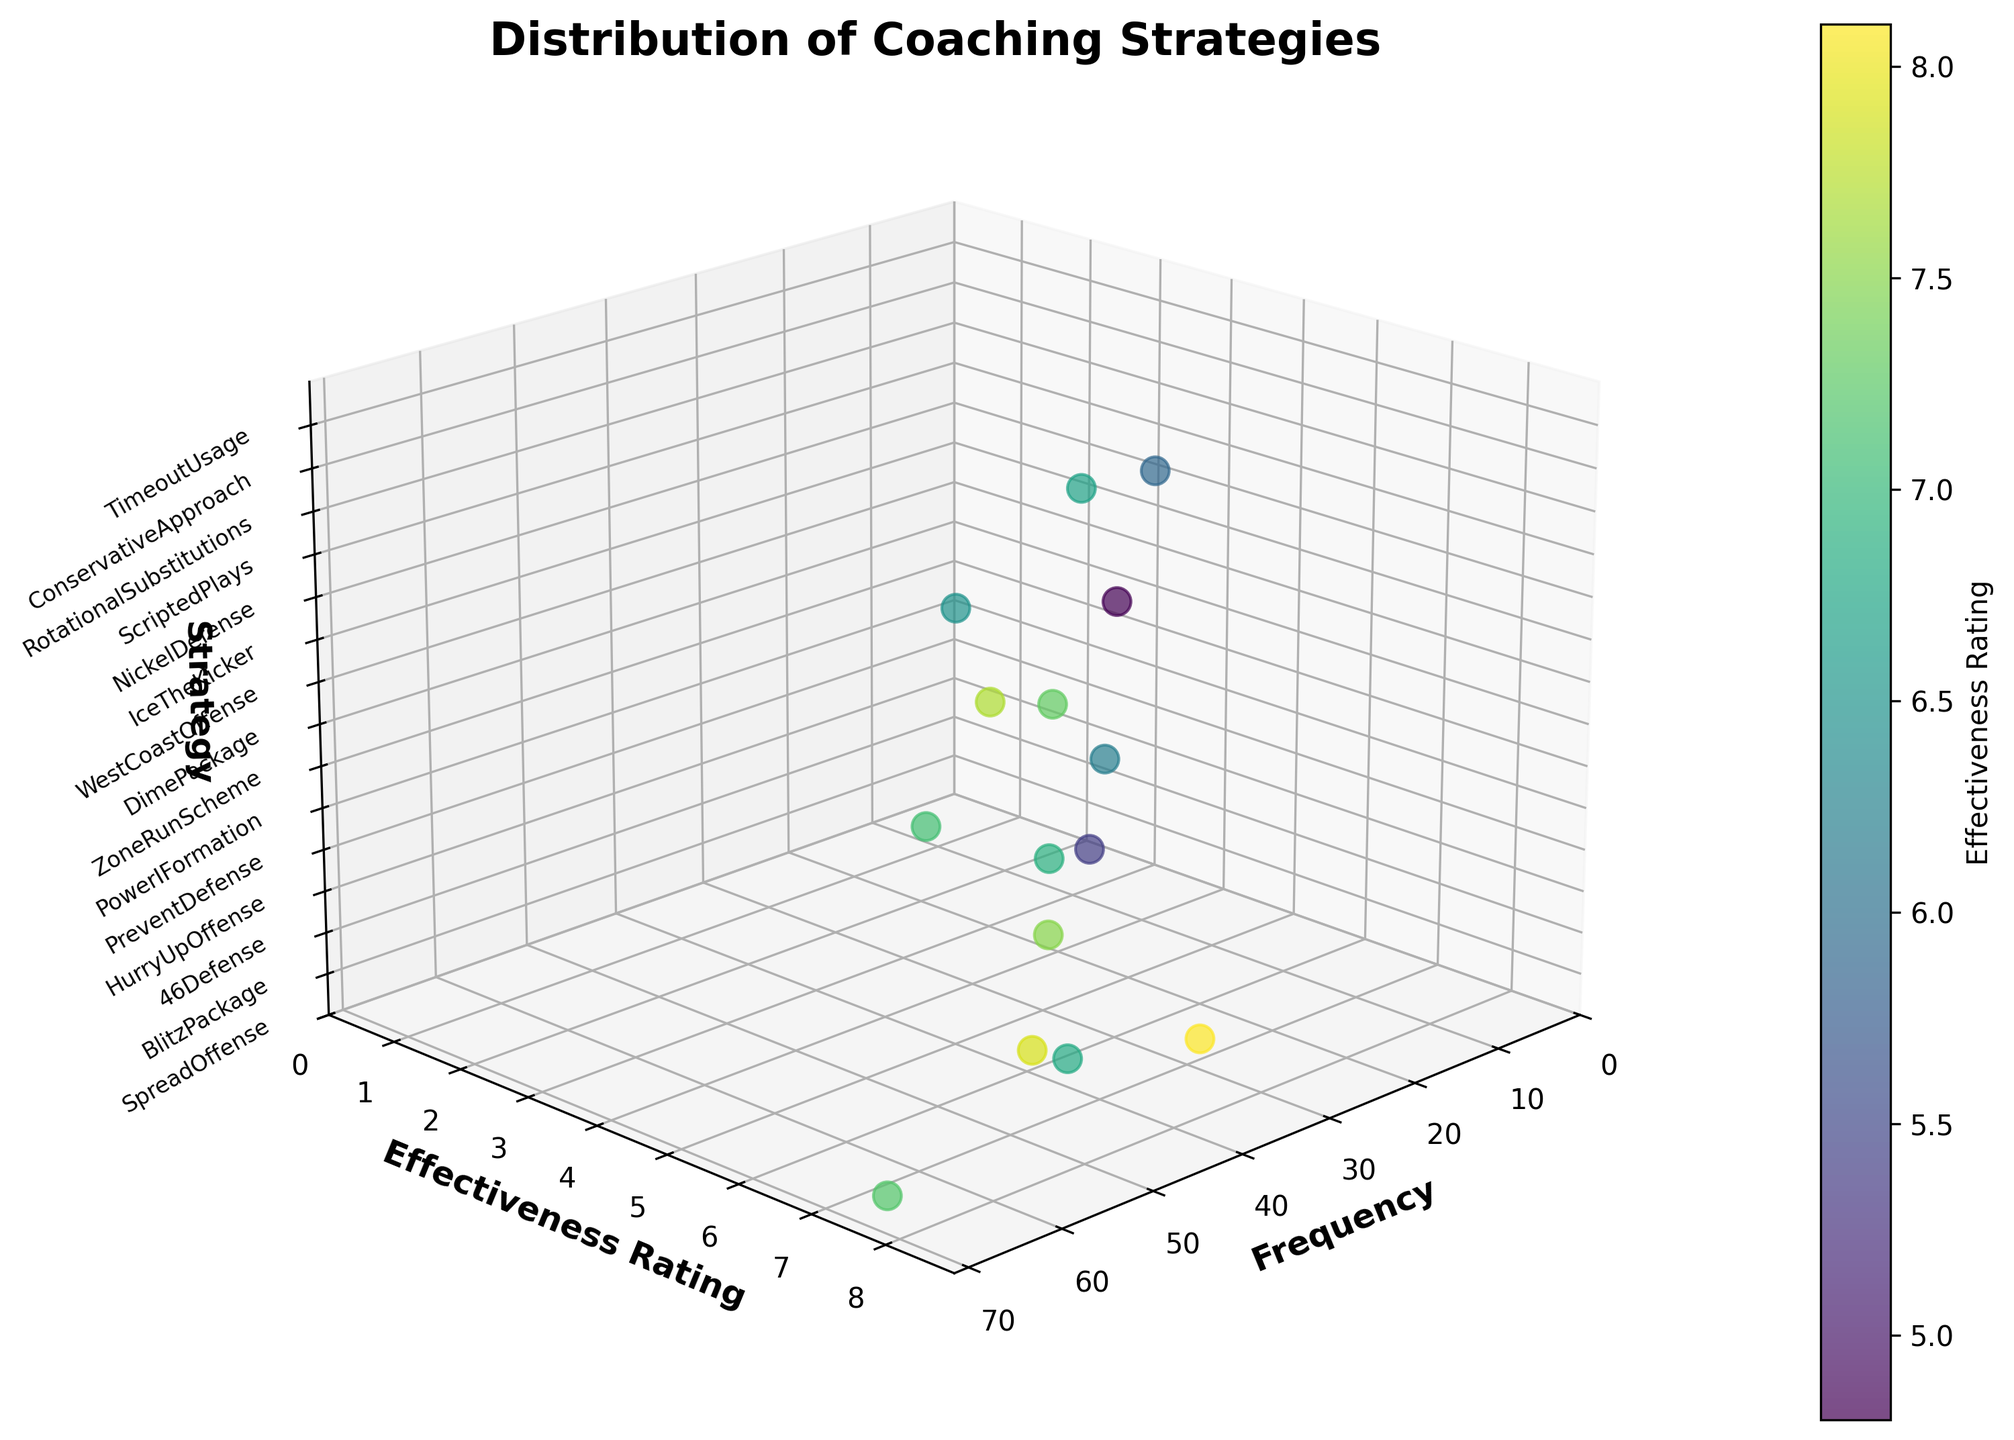What is the title of the figure? The title of the figure is always displayed at the top of the plot, providing a summary of the visual's content. In this case, the title is at the top of the 3D scatter plot.
Answer: Distribution of Coaching Strategies How many data points are represented in the scatter plot? The scatter plot has a specific number of data points representing the different strategies. By counting the markers, we can determine this number.
Answer: 15 Which strategy has the highest effectiveness rating? To find the highest effectiveness rating, scan the y-axis for the maximum value and trace it back to the corresponding strategy located near the top of the y-axis.
Answer: 46 Defense What is the range of frequencies shown on the x-axis? The range is determined by the minimum and maximum values along the x-axis. Observing the tick marks on this axis helps identify this range.
Answer: 0 to 65 Which strategy is used the least frequently? Find the smallest value on the x-axis, then trace it back to the corresponding strategy. The data point with the lowest frequency indicates the least used strategy.
Answer: Ice The Kicker What is the difference between the highest and lowest effectiveness ratings? Identify the highest and lowest points on the y-axis, then subtract the lowest value from the highest value to get the difference.
Answer: 8.1 - 4.8 = 3.3 Which two strategies have an effectiveness rating close to 7.1? Scan the y-axis for the value closest to 7.1, then locate the corresponding strategies. There should be two data points near this value.
Answer: Spread Offense, West Coast Offense What is the median frequency among the strategies? Arrange the frequencies in numerical order and find the middle number. If the number of data points is odd, the median is the middle number. If even, average the two middle numbers.
Answer: 45 Which strategy is represented by the data point furthest to the right on the plot? Locate the data point on the far right of the x-axis, which represents the highest frequency value, then match it with the corresponding strategy.
Answer: Spread Offense Compare the effectiveness ratings of 'Prevent Defense' and 'Timeout Usage'. Which is higher? Find the y-axis positions for both 'Prevent Defense' and 'Timeout Usage' and compare their positions. The one located higher on the y-axis has the higher rating.
Answer: Timeout Usage 